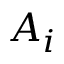Convert formula to latex. <formula><loc_0><loc_0><loc_500><loc_500>A _ { i }</formula> 